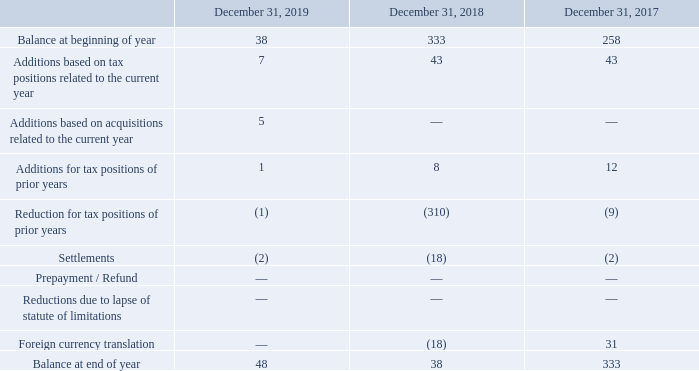At December 31, 2019 and 2018, $21 million and $20 million, respectively, of unrecognized tax benefits were classified as a reduction of deferred tax assets. The finalisation in the fourth quarter of 2018 of pending tax litigations triggered the reversal of uncertain tax positions in major tax jurisdictions for a total amount of $310 million.
It is reasonably possible that certain of the uncertain tax positions disclosed in the table above could increase within the next 12 months due to ongoing tax audits. The Company is not able to make an estimate of the range of the reasonably possible change.
Additionally, the Company elected to classify accrued interest and penalties related to uncertain tax positions as components of income tax expense in the consolidated statements of income, they were less than $1 million in 2019, $1 million in 2018, less than $1 million in 2017, $1 million in 2016, $1 million in 2015, $27 million in 2014 and not material in the previous years. Accrued interest and penalties amounted to $6 million at December 31, 2019 and $5 million at December 31, 2018.
The tax years that remain open for review in the Company’s major tax jurisdictions, including France, Italy, United States and India, are from 1997 to 2019.
How much unrecognized tax benefits were classified as a reduction of deferred tax assets as of December 31, 2019 and 2018? $21 million, $20 million. How much was the Accrued interest and penalties as of December 31, 2019? $6 million. How much was the Accrued interest and penalties as of December 31, 2019? $5 million. What is the increase/ (decrease) in Balance at beginning of year from December 31, 2018 to 2019?
Answer scale should be: million. 38-333
Answer: -295. What is the increase/ (decrease) in Balance at end of year from December 31, 2018 to 2019?
Answer scale should be: million. 48-38
Answer: 10. What is the increase/ (decrease) in Settlements from December 31, 2018 to 2019?
Answer scale should be: million. 2-18
Answer: -16. 